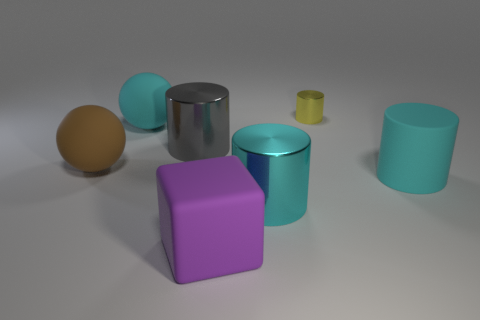What size is the gray metal object that is the same shape as the cyan metal thing? In the image, the gray metal object, which is a cylinder shape, appears to be of a medium size relative to the other objects depicted. It is not the largest nor the smallest piece displayed and is similar in size to the cyan-colored cylindrical object. 